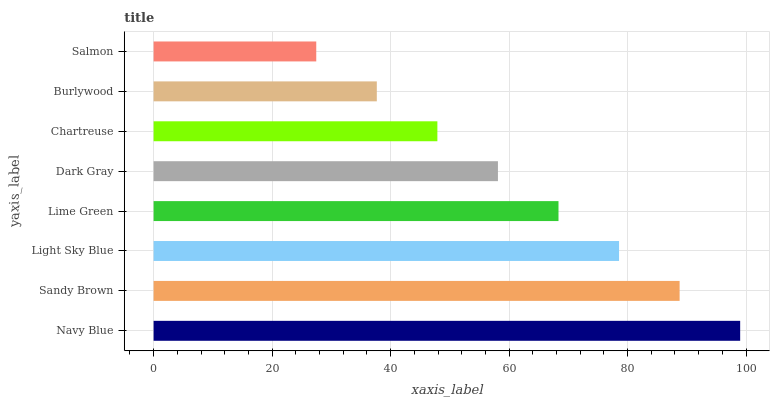Is Salmon the minimum?
Answer yes or no. Yes. Is Navy Blue the maximum?
Answer yes or no. Yes. Is Sandy Brown the minimum?
Answer yes or no. No. Is Sandy Brown the maximum?
Answer yes or no. No. Is Navy Blue greater than Sandy Brown?
Answer yes or no. Yes. Is Sandy Brown less than Navy Blue?
Answer yes or no. Yes. Is Sandy Brown greater than Navy Blue?
Answer yes or no. No. Is Navy Blue less than Sandy Brown?
Answer yes or no. No. Is Lime Green the high median?
Answer yes or no. Yes. Is Dark Gray the low median?
Answer yes or no. Yes. Is Light Sky Blue the high median?
Answer yes or no. No. Is Navy Blue the low median?
Answer yes or no. No. 